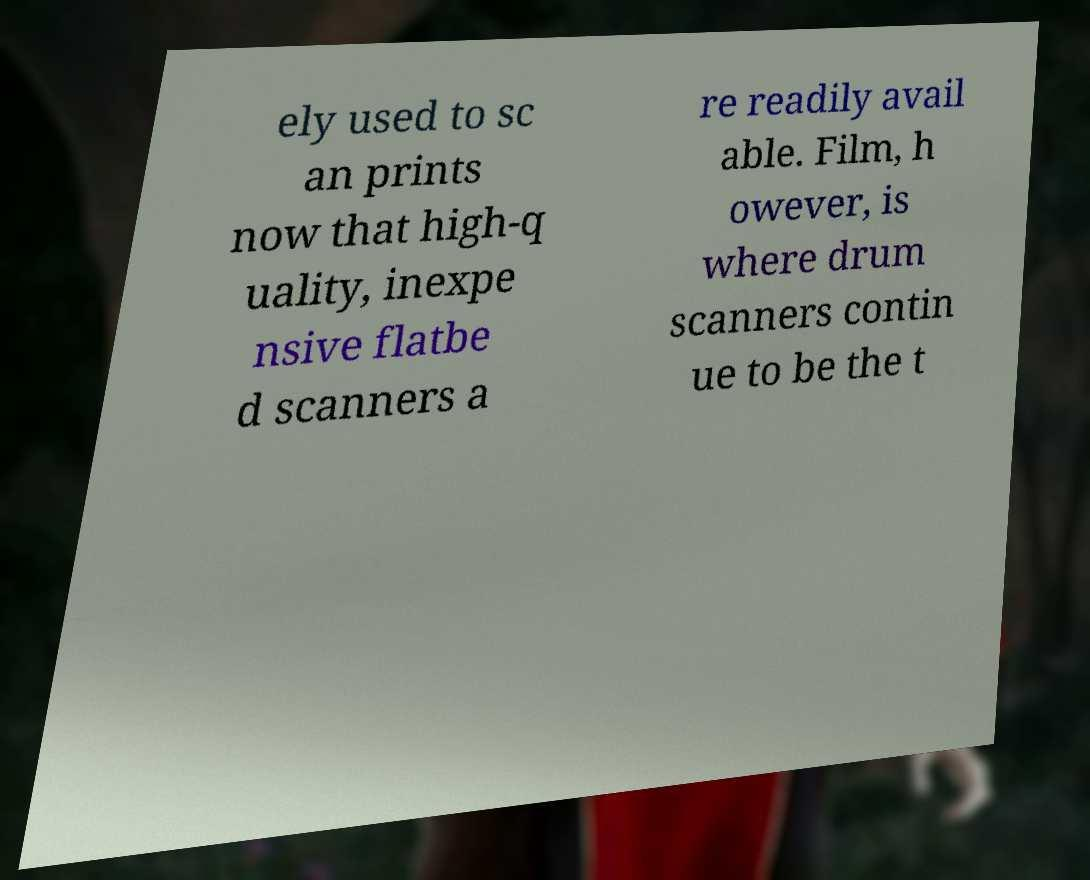For documentation purposes, I need the text within this image transcribed. Could you provide that? ely used to sc an prints now that high-q uality, inexpe nsive flatbe d scanners a re readily avail able. Film, h owever, is where drum scanners contin ue to be the t 